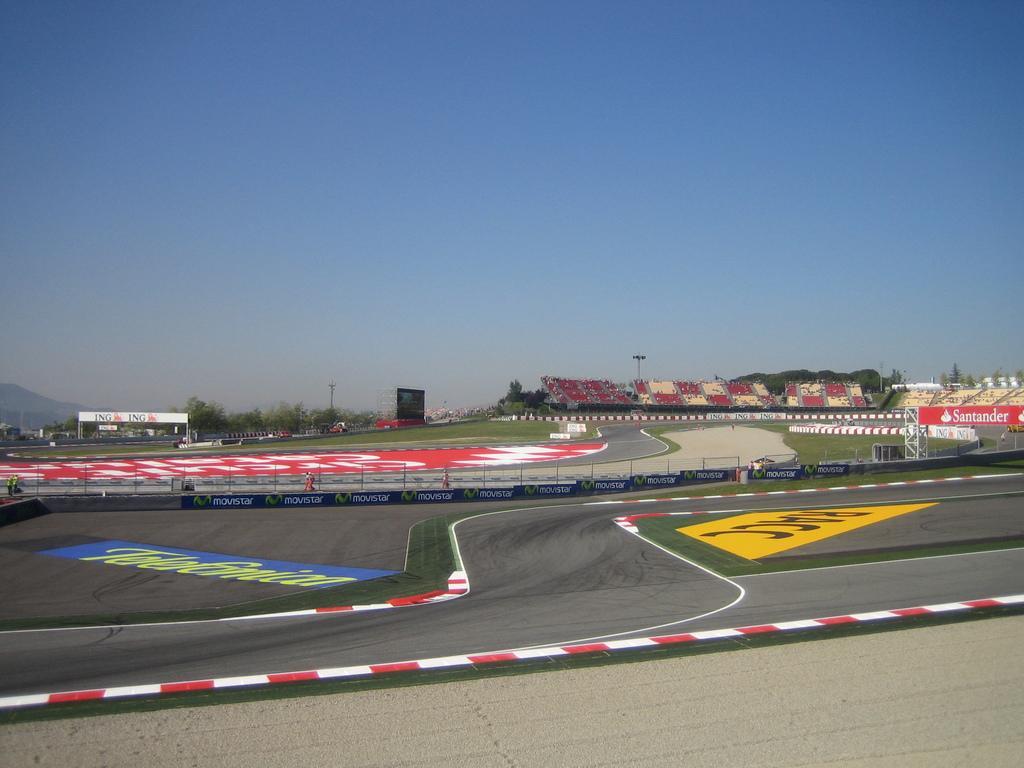How would you summarize this image in a sentence or two? In this image there are roads and we can see boards. There are poles and trees. In the background there are hills and sky. 